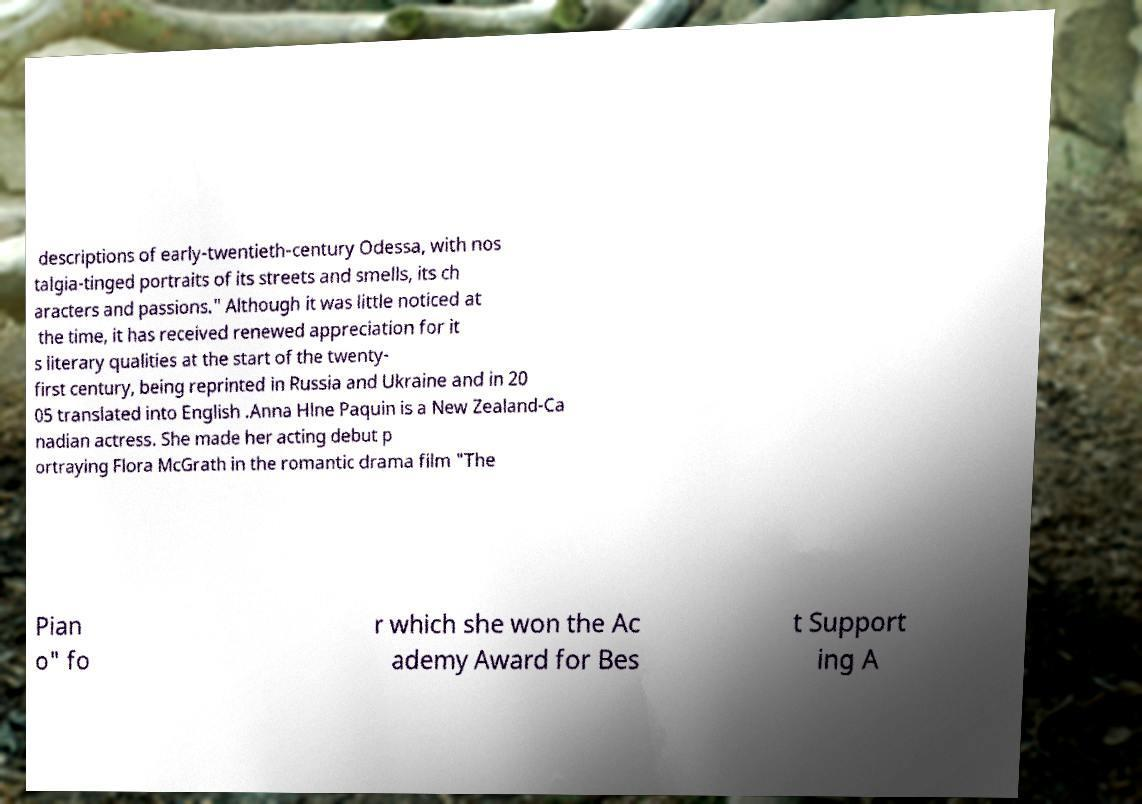For documentation purposes, I need the text within this image transcribed. Could you provide that? descriptions of early-twentieth-century Odessa, with nos talgia-tinged portraits of its streets and smells, its ch aracters and passions." Although it was little noticed at the time, it has received renewed appreciation for it s literary qualities at the start of the twenty- first century, being reprinted in Russia and Ukraine and in 20 05 translated into English .Anna Hlne Paquin is a New Zealand-Ca nadian actress. She made her acting debut p ortraying Flora McGrath in the romantic drama film "The Pian o" fo r which she won the Ac ademy Award for Bes t Support ing A 